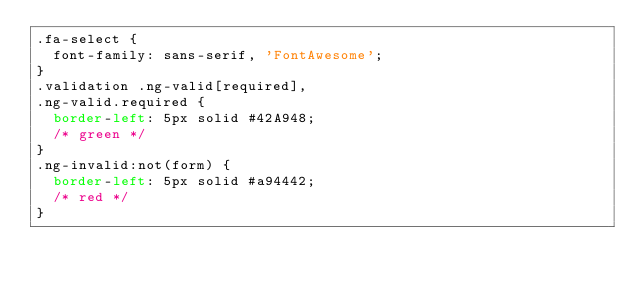Convert code to text. <code><loc_0><loc_0><loc_500><loc_500><_CSS_>.fa-select {
  font-family: sans-serif, 'FontAwesome';
}
.validation .ng-valid[required],
.ng-valid.required {
  border-left: 5px solid #42A948;
  /* green */
}
.ng-invalid:not(form) {
  border-left: 5px solid #a94442;
  /* red */
}
</code> 